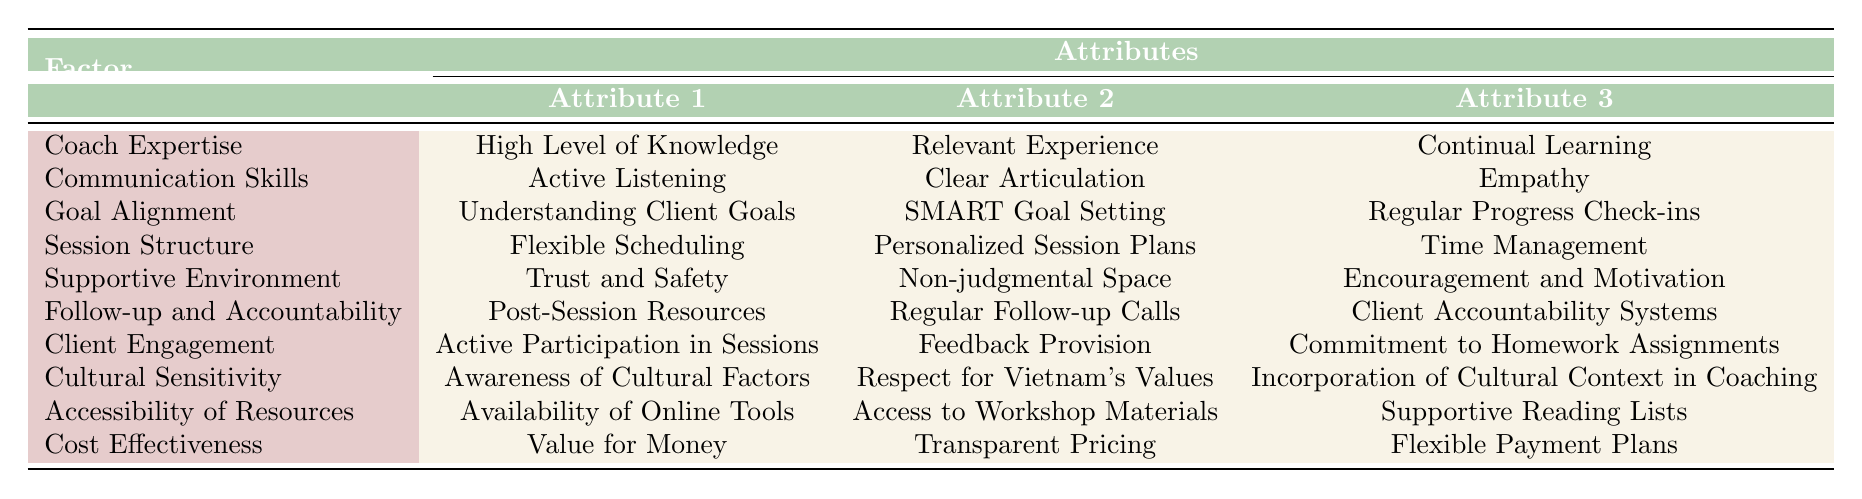What are the three attributes of Coach Expertise? In the table, under the "Coach Expertise" factor, the three attributes listed are "High Level of Knowledge," "Relevant Experience," and "Continual Learning."
Answer: High Level of Knowledge, Relevant Experience, Continual Learning Is Active Listening an attribute of Client Engagement? By looking at the "Client Engagement" row in the table, it clearly shows that "Active Participation in Sessions," "Feedback Provision," and "Commitment to Homework Assignments" are the attributes. "Active Listening" is actually listed under "Communication Skills," making this statement false.
Answer: No Which factor has the attribute "Encouragement and Motivation"? In the "Supportive Environment" row of the table, "Encouragement and Motivation" is one of the attributes listed.
Answer: Supportive Environment How many attributes are listed for Cultural Sensitivity? The "Cultural Sensitivity" factor in the table shows three attributes: "Awareness of Cultural Factors," "Respect for Vietnam's Values," and "Incorporation of Cultural Context in Coaching." Therefore, there are three attributes.
Answer: Three If we consider the factors of Coach Expertise and Communication Skills, how many total attributes do they have combined? Coach Expertise has three attributes: "High Level of Knowledge," "Relevant Experience," "Continual Learning." Communication Skills also has three attributes: "Active Listening," "Clear Articulation," and "Empathy." Adding them together gives a total of 6 attributes.
Answer: Six Is the attribute "Regular Progress Check-ins" related to Goal Alignment? The "Regular Progress Check-ins" attribute appears under the "Goal Alignment" factor in the table, confirming that it indeed relates to Goal Alignment.
Answer: Yes Which factor includes "Transparent Pricing"? The "Cost Effectiveness" factor in the table includes "Transparent Pricing" as one of its attributes.
Answer: Cost Effectiveness What is the relationship between Client Engagement and Feedback Provision? "Feedback Provision" is listed as an attribute under the "Client Engagement" factor. This indicates that actively seeking and providing feedback is essential for engaging clients during personal coaching sessions.
Answer: Direct relationship 